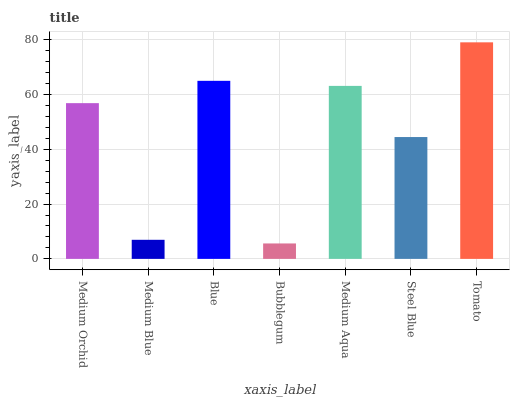Is Bubblegum the minimum?
Answer yes or no. Yes. Is Tomato the maximum?
Answer yes or no. Yes. Is Medium Blue the minimum?
Answer yes or no. No. Is Medium Blue the maximum?
Answer yes or no. No. Is Medium Orchid greater than Medium Blue?
Answer yes or no. Yes. Is Medium Blue less than Medium Orchid?
Answer yes or no. Yes. Is Medium Blue greater than Medium Orchid?
Answer yes or no. No. Is Medium Orchid less than Medium Blue?
Answer yes or no. No. Is Medium Orchid the high median?
Answer yes or no. Yes. Is Medium Orchid the low median?
Answer yes or no. Yes. Is Bubblegum the high median?
Answer yes or no. No. Is Blue the low median?
Answer yes or no. No. 